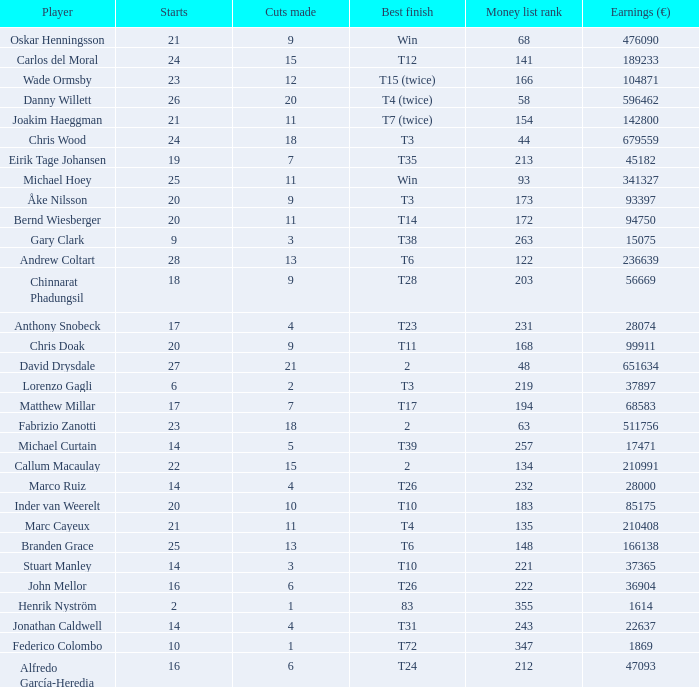How many cuts did the player who earned 210408 Euro make? 11.0. 